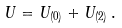Convert formula to latex. <formula><loc_0><loc_0><loc_500><loc_500>U = U _ { ( 0 ) } + U _ { ( 2 ) } \, .</formula> 